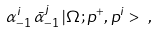<formula> <loc_0><loc_0><loc_500><loc_500>\alpha ^ { i } _ { - 1 } \, \bar { \alpha } ^ { j } _ { - 1 } \, | \Omega ; p ^ { + } , p ^ { i } > \ ,</formula> 